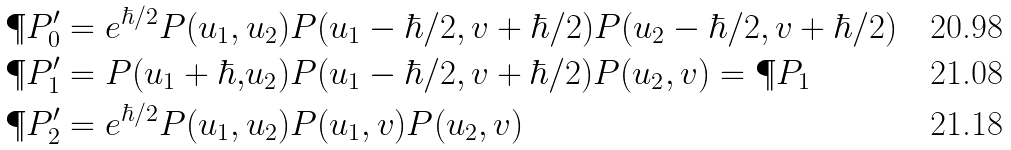Convert formula to latex. <formula><loc_0><loc_0><loc_500><loc_500>\P P _ { 0 } ^ { \prime } & = e ^ { \hbar { / } 2 } P ( u _ { 1 } , u _ { 2 } ) P ( u _ { 1 } - \hbar { / } 2 , v + \hbar { / } 2 ) P ( u _ { 2 } - \hbar { / } 2 , v + \hbar { / } 2 ) \\ \P P _ { 1 } ^ { \prime } & = P ( u _ { 1 } + \hbar { , } u _ { 2 } ) P ( u _ { 1 } - \hbar { / } 2 , v + \hbar { / } 2 ) P ( u _ { 2 } , v ) = \P P _ { 1 } \\ \P P _ { 2 } ^ { \prime } & = e ^ { \hbar { / } 2 } P ( u _ { 1 } , u _ { 2 } ) P ( u _ { 1 } , v ) P ( u _ { 2 } , v )</formula> 